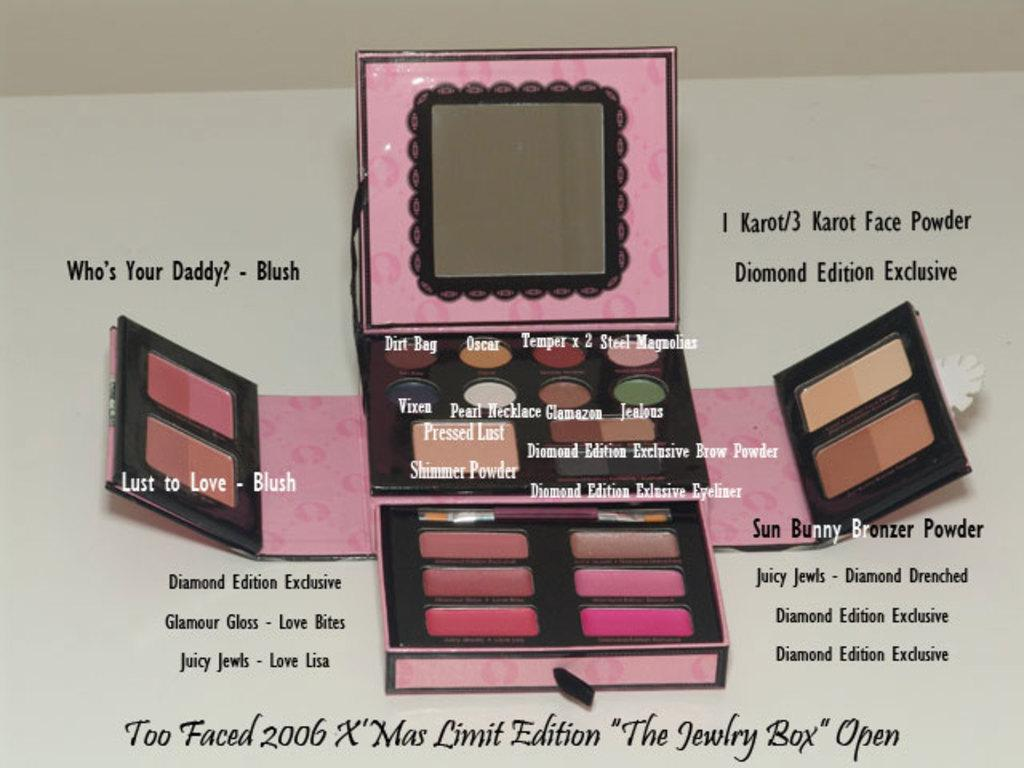<image>
Describe the image concisely. A picture of Too Faced 2006 X'mas Limit Edition "The Jewelry Box" 